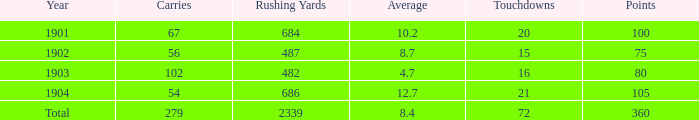What is the maximum amount of touchdowns with less than 105 points, an average above None. 